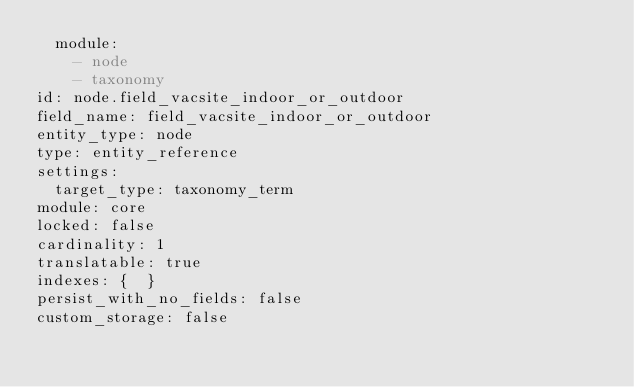<code> <loc_0><loc_0><loc_500><loc_500><_YAML_>  module:
    - node
    - taxonomy
id: node.field_vacsite_indoor_or_outdoor
field_name: field_vacsite_indoor_or_outdoor
entity_type: node
type: entity_reference
settings:
  target_type: taxonomy_term
module: core
locked: false
cardinality: 1
translatable: true
indexes: {  }
persist_with_no_fields: false
custom_storage: false
</code> 